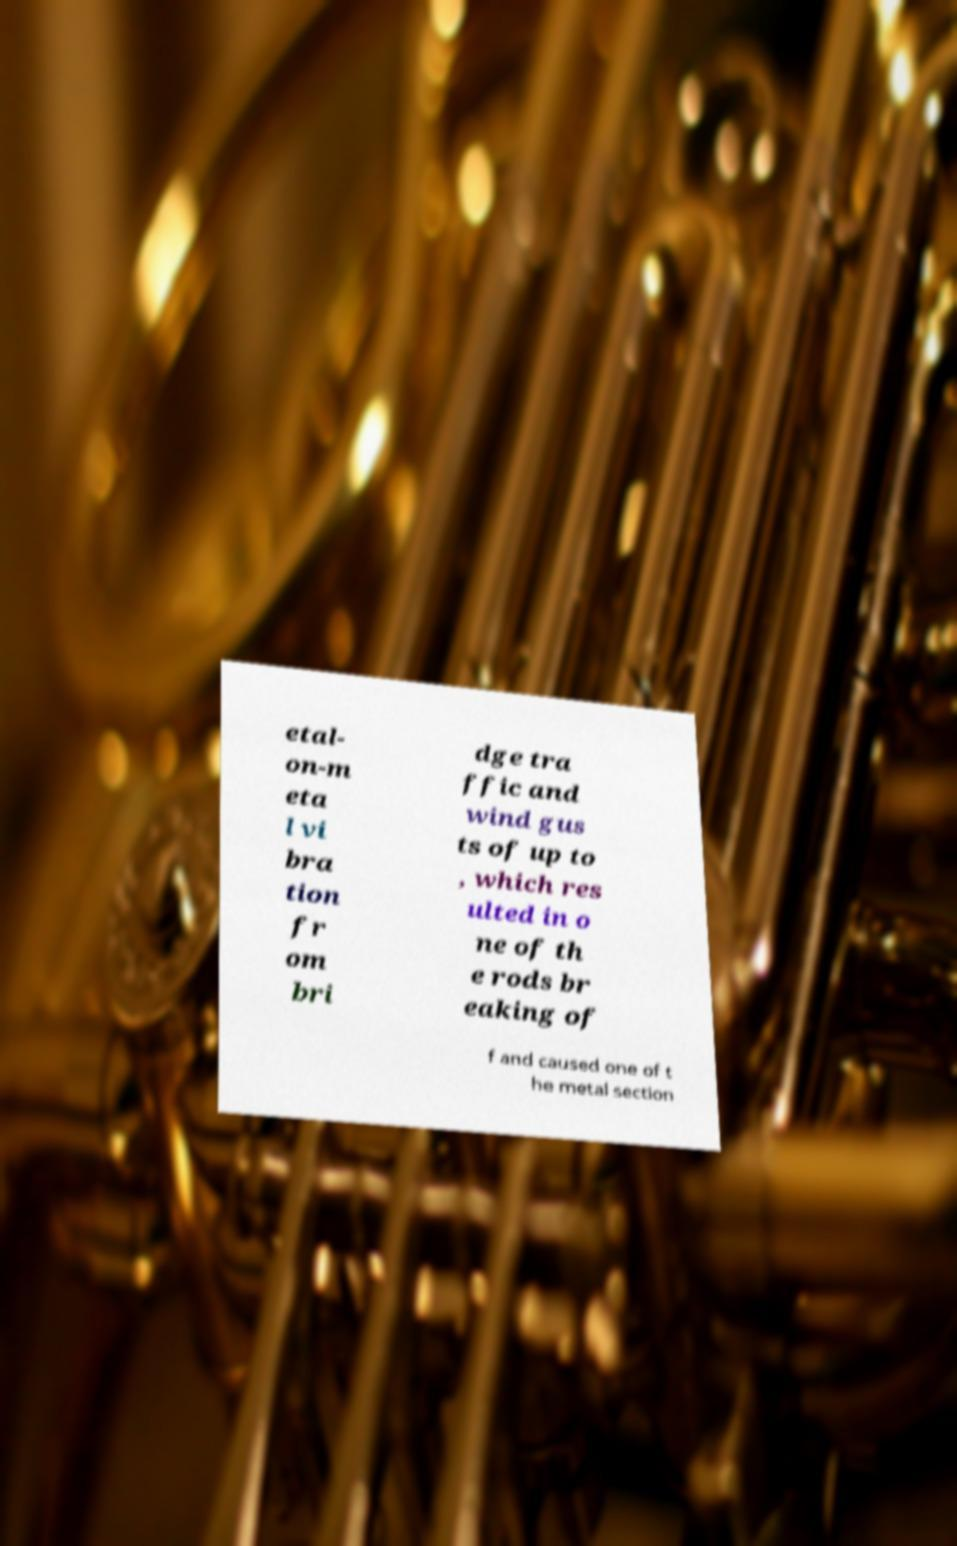Can you read and provide the text displayed in the image?This photo seems to have some interesting text. Can you extract and type it out for me? etal- on-m eta l vi bra tion fr om bri dge tra ffic and wind gus ts of up to , which res ulted in o ne of th e rods br eaking of f and caused one of t he metal section 